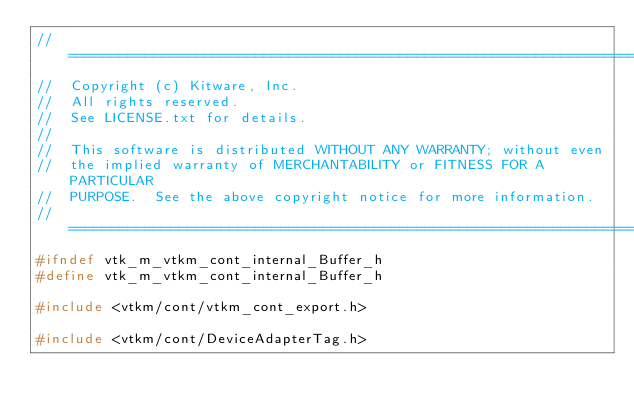Convert code to text. <code><loc_0><loc_0><loc_500><loc_500><_C_>//============================================================================
//  Copyright (c) Kitware, Inc.
//  All rights reserved.
//  See LICENSE.txt for details.
//
//  This software is distributed WITHOUT ANY WARRANTY; without even
//  the implied warranty of MERCHANTABILITY or FITNESS FOR A PARTICULAR
//  PURPOSE.  See the above copyright notice for more information.
//============================================================================
#ifndef vtk_m_vtkm_cont_internal_Buffer_h
#define vtk_m_vtkm_cont_internal_Buffer_h

#include <vtkm/cont/vtkm_cont_export.h>

#include <vtkm/cont/DeviceAdapterTag.h></code> 